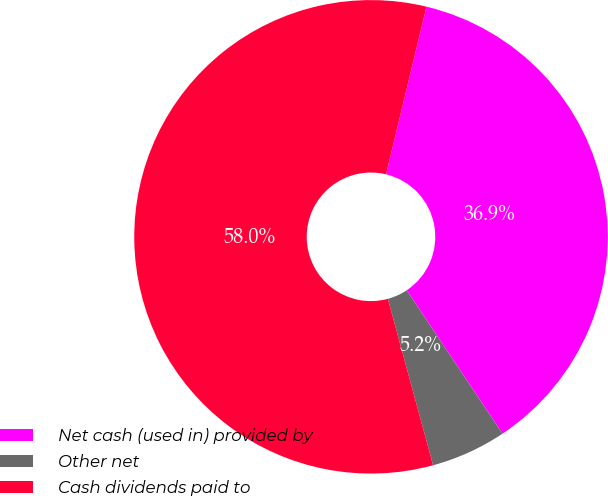<chart> <loc_0><loc_0><loc_500><loc_500><pie_chart><fcel>Net cash (used in) provided by<fcel>Other net<fcel>Cash dividends paid to<nl><fcel>36.86%<fcel>5.15%<fcel>57.99%<nl></chart> 